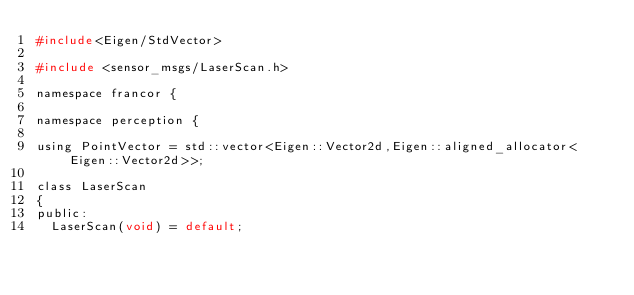<code> <loc_0><loc_0><loc_500><loc_500><_C_>#include<Eigen/StdVector>

#include <sensor_msgs/LaserScan.h>

namespace francor {

namespace perception {

using PointVector = std::vector<Eigen::Vector2d,Eigen::aligned_allocator<Eigen::Vector2d>>;

class LaserScan
{
public:
  LaserScan(void) = default;</code> 